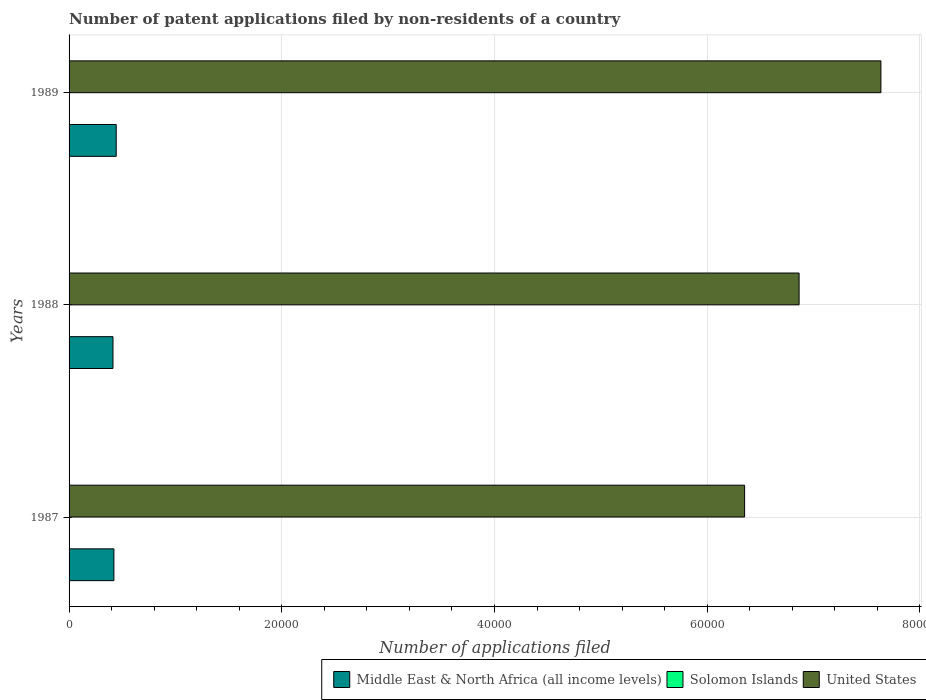How many different coloured bars are there?
Ensure brevity in your answer.  3. Are the number of bars per tick equal to the number of legend labels?
Provide a short and direct response. Yes. Are the number of bars on each tick of the Y-axis equal?
Offer a very short reply. Yes. What is the label of the 1st group of bars from the top?
Keep it short and to the point. 1989. Across all years, what is the minimum number of applications filed in Solomon Islands?
Ensure brevity in your answer.  2. In which year was the number of applications filed in Solomon Islands maximum?
Keep it short and to the point. 1987. What is the total number of applications filed in Solomon Islands in the graph?
Offer a very short reply. 10. What is the difference between the number of applications filed in United States in 1988 and that in 1989?
Provide a succinct answer. -7693. What is the difference between the number of applications filed in Solomon Islands in 1987 and the number of applications filed in United States in 1988?
Your answer should be very brief. -6.86e+04. What is the average number of applications filed in Solomon Islands per year?
Keep it short and to the point. 3.33. In the year 1989, what is the difference between the number of applications filed in Middle East & North Africa (all income levels) and number of applications filed in Solomon Islands?
Ensure brevity in your answer.  4431. What is the ratio of the number of applications filed in Middle East & North Africa (all income levels) in 1987 to that in 1988?
Your answer should be compact. 1.02. What is the difference between the highest and the second highest number of applications filed in Middle East & North Africa (all income levels)?
Your response must be concise. 217. What is the difference between the highest and the lowest number of applications filed in Solomon Islands?
Your answer should be compact. 4. What does the 1st bar from the top in 1988 represents?
Ensure brevity in your answer.  United States. What does the 2nd bar from the bottom in 1989 represents?
Keep it short and to the point. Solomon Islands. How many bars are there?
Ensure brevity in your answer.  9. Are all the bars in the graph horizontal?
Offer a terse response. Yes. Does the graph contain any zero values?
Offer a terse response. No. Where does the legend appear in the graph?
Your answer should be very brief. Bottom right. How are the legend labels stacked?
Your answer should be very brief. Horizontal. What is the title of the graph?
Your response must be concise. Number of patent applications filed by non-residents of a country. What is the label or title of the X-axis?
Provide a short and direct response. Number of applications filed. What is the label or title of the Y-axis?
Offer a very short reply. Years. What is the Number of applications filed in Middle East & North Africa (all income levels) in 1987?
Provide a short and direct response. 4216. What is the Number of applications filed of United States in 1987?
Provide a succinct answer. 6.35e+04. What is the Number of applications filed of Middle East & North Africa (all income levels) in 1988?
Provide a succinct answer. 4129. What is the Number of applications filed of United States in 1988?
Your answer should be compact. 6.86e+04. What is the Number of applications filed in Middle East & North Africa (all income levels) in 1989?
Offer a terse response. 4433. What is the Number of applications filed in Solomon Islands in 1989?
Ensure brevity in your answer.  2. What is the Number of applications filed in United States in 1989?
Make the answer very short. 7.63e+04. Across all years, what is the maximum Number of applications filed in Middle East & North Africa (all income levels)?
Keep it short and to the point. 4433. Across all years, what is the maximum Number of applications filed in Solomon Islands?
Offer a terse response. 6. Across all years, what is the maximum Number of applications filed of United States?
Offer a terse response. 7.63e+04. Across all years, what is the minimum Number of applications filed of Middle East & North Africa (all income levels)?
Your response must be concise. 4129. Across all years, what is the minimum Number of applications filed of United States?
Give a very brief answer. 6.35e+04. What is the total Number of applications filed in Middle East & North Africa (all income levels) in the graph?
Provide a short and direct response. 1.28e+04. What is the total Number of applications filed of United States in the graph?
Give a very brief answer. 2.09e+05. What is the difference between the Number of applications filed of United States in 1987 and that in 1988?
Make the answer very short. -5122. What is the difference between the Number of applications filed of Middle East & North Africa (all income levels) in 1987 and that in 1989?
Offer a terse response. -217. What is the difference between the Number of applications filed in Solomon Islands in 1987 and that in 1989?
Make the answer very short. 4. What is the difference between the Number of applications filed in United States in 1987 and that in 1989?
Make the answer very short. -1.28e+04. What is the difference between the Number of applications filed of Middle East & North Africa (all income levels) in 1988 and that in 1989?
Provide a short and direct response. -304. What is the difference between the Number of applications filed in Solomon Islands in 1988 and that in 1989?
Offer a terse response. 0. What is the difference between the Number of applications filed in United States in 1988 and that in 1989?
Your answer should be compact. -7693. What is the difference between the Number of applications filed of Middle East & North Africa (all income levels) in 1987 and the Number of applications filed of Solomon Islands in 1988?
Provide a short and direct response. 4214. What is the difference between the Number of applications filed of Middle East & North Africa (all income levels) in 1987 and the Number of applications filed of United States in 1988?
Your response must be concise. -6.44e+04. What is the difference between the Number of applications filed of Solomon Islands in 1987 and the Number of applications filed of United States in 1988?
Keep it short and to the point. -6.86e+04. What is the difference between the Number of applications filed in Middle East & North Africa (all income levels) in 1987 and the Number of applications filed in Solomon Islands in 1989?
Make the answer very short. 4214. What is the difference between the Number of applications filed of Middle East & North Africa (all income levels) in 1987 and the Number of applications filed of United States in 1989?
Offer a very short reply. -7.21e+04. What is the difference between the Number of applications filed in Solomon Islands in 1987 and the Number of applications filed in United States in 1989?
Ensure brevity in your answer.  -7.63e+04. What is the difference between the Number of applications filed in Middle East & North Africa (all income levels) in 1988 and the Number of applications filed in Solomon Islands in 1989?
Make the answer very short. 4127. What is the difference between the Number of applications filed of Middle East & North Africa (all income levels) in 1988 and the Number of applications filed of United States in 1989?
Give a very brief answer. -7.22e+04. What is the difference between the Number of applications filed in Solomon Islands in 1988 and the Number of applications filed in United States in 1989?
Ensure brevity in your answer.  -7.63e+04. What is the average Number of applications filed in Middle East & North Africa (all income levels) per year?
Provide a succinct answer. 4259.33. What is the average Number of applications filed in Solomon Islands per year?
Ensure brevity in your answer.  3.33. What is the average Number of applications filed in United States per year?
Offer a very short reply. 6.95e+04. In the year 1987, what is the difference between the Number of applications filed of Middle East & North Africa (all income levels) and Number of applications filed of Solomon Islands?
Make the answer very short. 4210. In the year 1987, what is the difference between the Number of applications filed of Middle East & North Africa (all income levels) and Number of applications filed of United States?
Keep it short and to the point. -5.93e+04. In the year 1987, what is the difference between the Number of applications filed in Solomon Islands and Number of applications filed in United States?
Offer a very short reply. -6.35e+04. In the year 1988, what is the difference between the Number of applications filed in Middle East & North Africa (all income levels) and Number of applications filed in Solomon Islands?
Your answer should be very brief. 4127. In the year 1988, what is the difference between the Number of applications filed of Middle East & North Africa (all income levels) and Number of applications filed of United States?
Offer a very short reply. -6.45e+04. In the year 1988, what is the difference between the Number of applications filed of Solomon Islands and Number of applications filed of United States?
Your response must be concise. -6.86e+04. In the year 1989, what is the difference between the Number of applications filed of Middle East & North Africa (all income levels) and Number of applications filed of Solomon Islands?
Your answer should be very brief. 4431. In the year 1989, what is the difference between the Number of applications filed of Middle East & North Africa (all income levels) and Number of applications filed of United States?
Your response must be concise. -7.19e+04. In the year 1989, what is the difference between the Number of applications filed in Solomon Islands and Number of applications filed in United States?
Make the answer very short. -7.63e+04. What is the ratio of the Number of applications filed in Middle East & North Africa (all income levels) in 1987 to that in 1988?
Provide a succinct answer. 1.02. What is the ratio of the Number of applications filed of Solomon Islands in 1987 to that in 1988?
Ensure brevity in your answer.  3. What is the ratio of the Number of applications filed of United States in 1987 to that in 1988?
Offer a terse response. 0.93. What is the ratio of the Number of applications filed of Middle East & North Africa (all income levels) in 1987 to that in 1989?
Offer a very short reply. 0.95. What is the ratio of the Number of applications filed of Solomon Islands in 1987 to that in 1989?
Make the answer very short. 3. What is the ratio of the Number of applications filed in United States in 1987 to that in 1989?
Provide a succinct answer. 0.83. What is the ratio of the Number of applications filed in Middle East & North Africa (all income levels) in 1988 to that in 1989?
Provide a succinct answer. 0.93. What is the ratio of the Number of applications filed of Solomon Islands in 1988 to that in 1989?
Ensure brevity in your answer.  1. What is the ratio of the Number of applications filed in United States in 1988 to that in 1989?
Provide a succinct answer. 0.9. What is the difference between the highest and the second highest Number of applications filed of Middle East & North Africa (all income levels)?
Provide a succinct answer. 217. What is the difference between the highest and the second highest Number of applications filed in Solomon Islands?
Offer a very short reply. 4. What is the difference between the highest and the second highest Number of applications filed of United States?
Ensure brevity in your answer.  7693. What is the difference between the highest and the lowest Number of applications filed of Middle East & North Africa (all income levels)?
Offer a terse response. 304. What is the difference between the highest and the lowest Number of applications filed of United States?
Make the answer very short. 1.28e+04. 